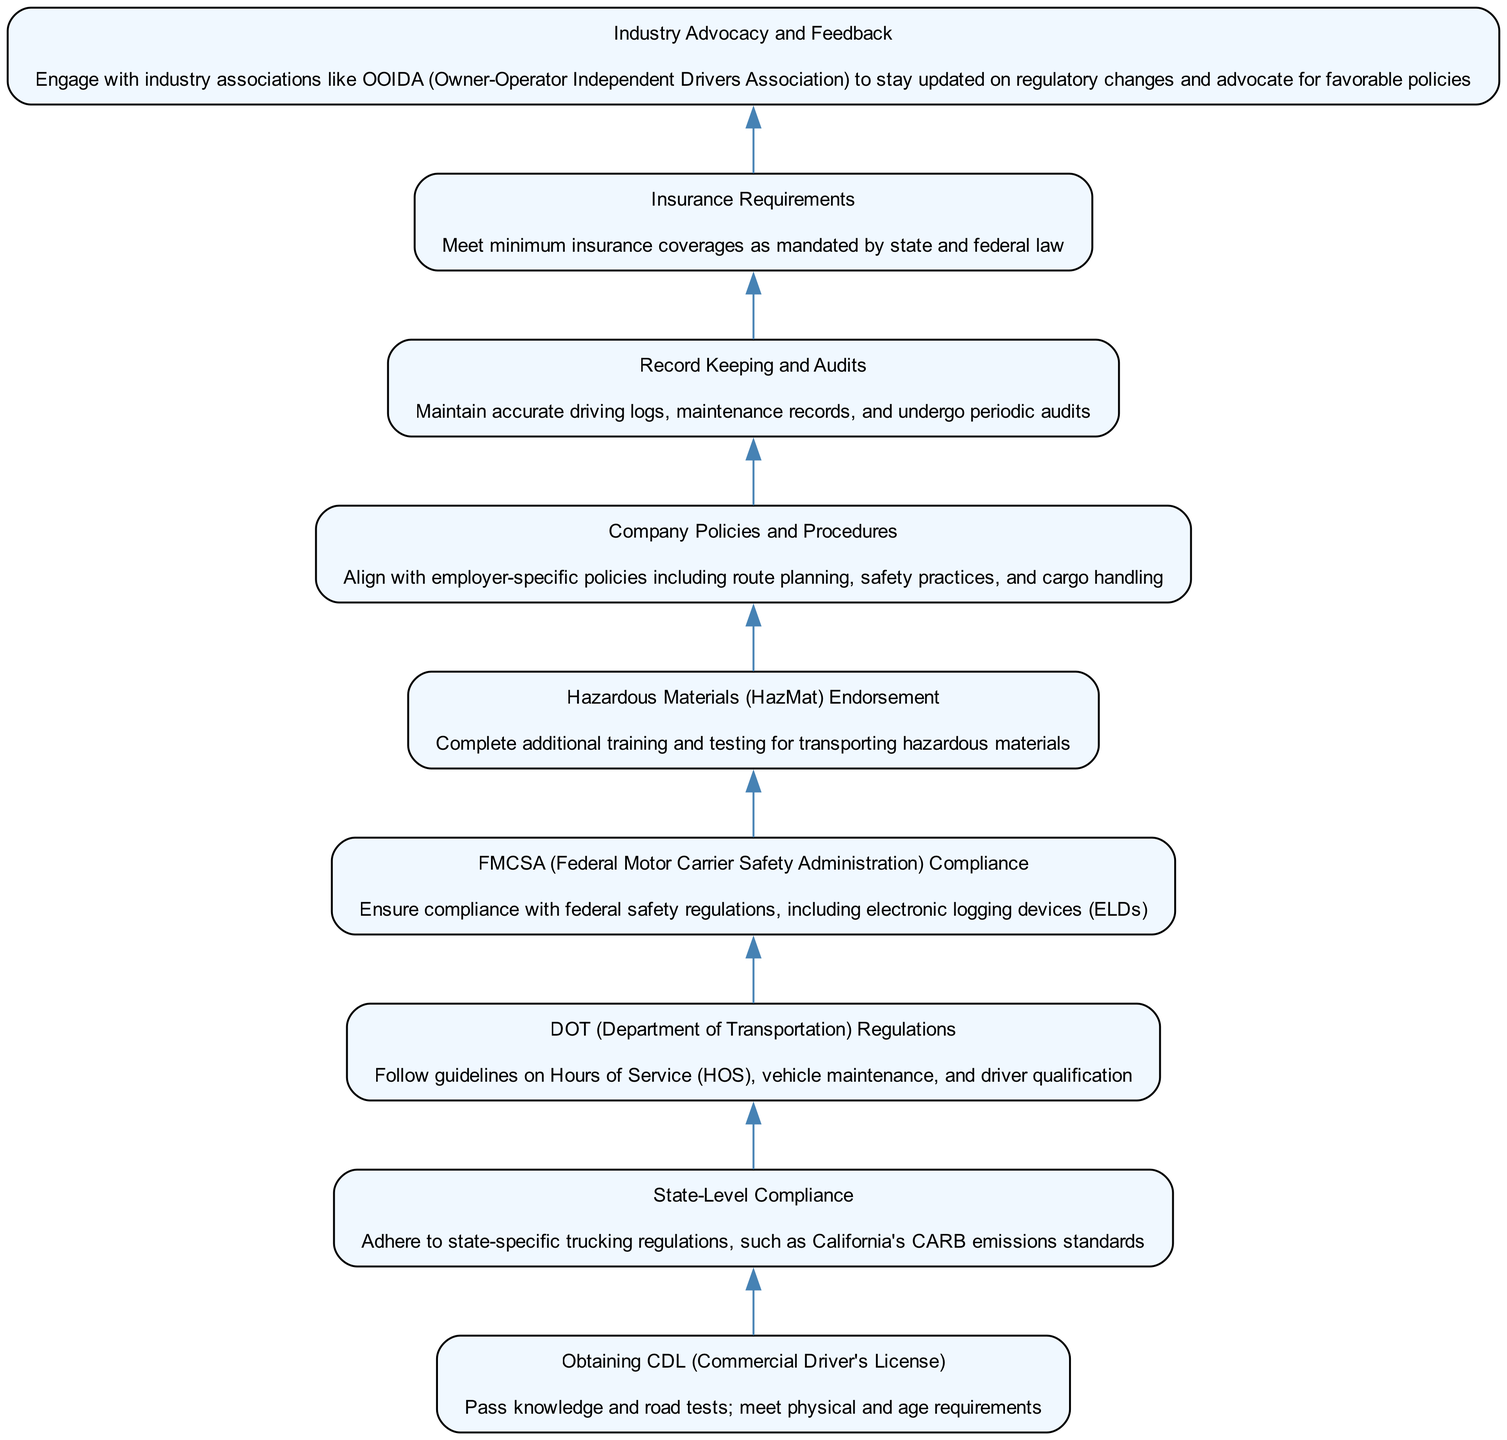What is the first element in the flow chart? The first element, at the bottom, is "Obtaining CDL (Commercial Driver's License)", which is the initial step in navigating regulatory requirements.
Answer: Obtaining CDL (Commercial Driver's License) How many total elements are in the flow chart? There are 9 elements listed in the flow chart, each representing a regulatory step.
Answer: 9 What element involves additional training? The element that involves additional training is "Hazardous Materials (HazMat) Endorsement". This endorsement requires completing training and testing for transporting hazardous materials.
Answer: Hazardous Materials (HazMat) Endorsement Which element comes directly after "State-Level Compliance"? The element that comes directly after "State-Level Compliance" is "DOT (Department of Transportation) Regulations", indicating a progression from state to federal regulations.
Answer: DOT (Department of Transportation) Regulations What is the last step in the flow chart? The last step, or the top-most element, is "Industry Advocacy and Feedback", showing the importance of engagement with industry associations for ongoing compliance and advocacy.
Answer: Industry Advocacy and Feedback How does "Company Policies and Procedures" relate to "DOT (Department of Transportation) Regulations"? "Company Policies and Procedures" is positioned above "DOT (Department of Transportation) Regulations", indicating that after adhering to DOT regulations, drivers must align with specific company policies that may further govern their operations.
Answer: Align with employer-specific policies What documentation is maintained in the "Record Keeping and Audits" step? In this step, "Record Keeping and Audits" involves maintaining accurate driving logs and maintenance records, essential for compliance and audit readiness.
Answer: Driving logs, maintenance records How does the flow demonstrate the hierarchy of regulations? The flow visually demonstrates a hierarchy beginning from obtaining a CDL at the bottom, evolving through state and federal regulations, and culminating in advocacy, indicating that each step builds upon the previous requirements.
Answer: Hierarchy from local to federal compliance What element addresses safety regulations at the federal level? The element that addresses safety regulations at the federal level is "FMCSA (Federal Motor Carrier Safety Administration) Compliance", which includes important safety guidelines.
Answer: FMCSA (Federal Motor Carrier Safety Administration) Compliance 